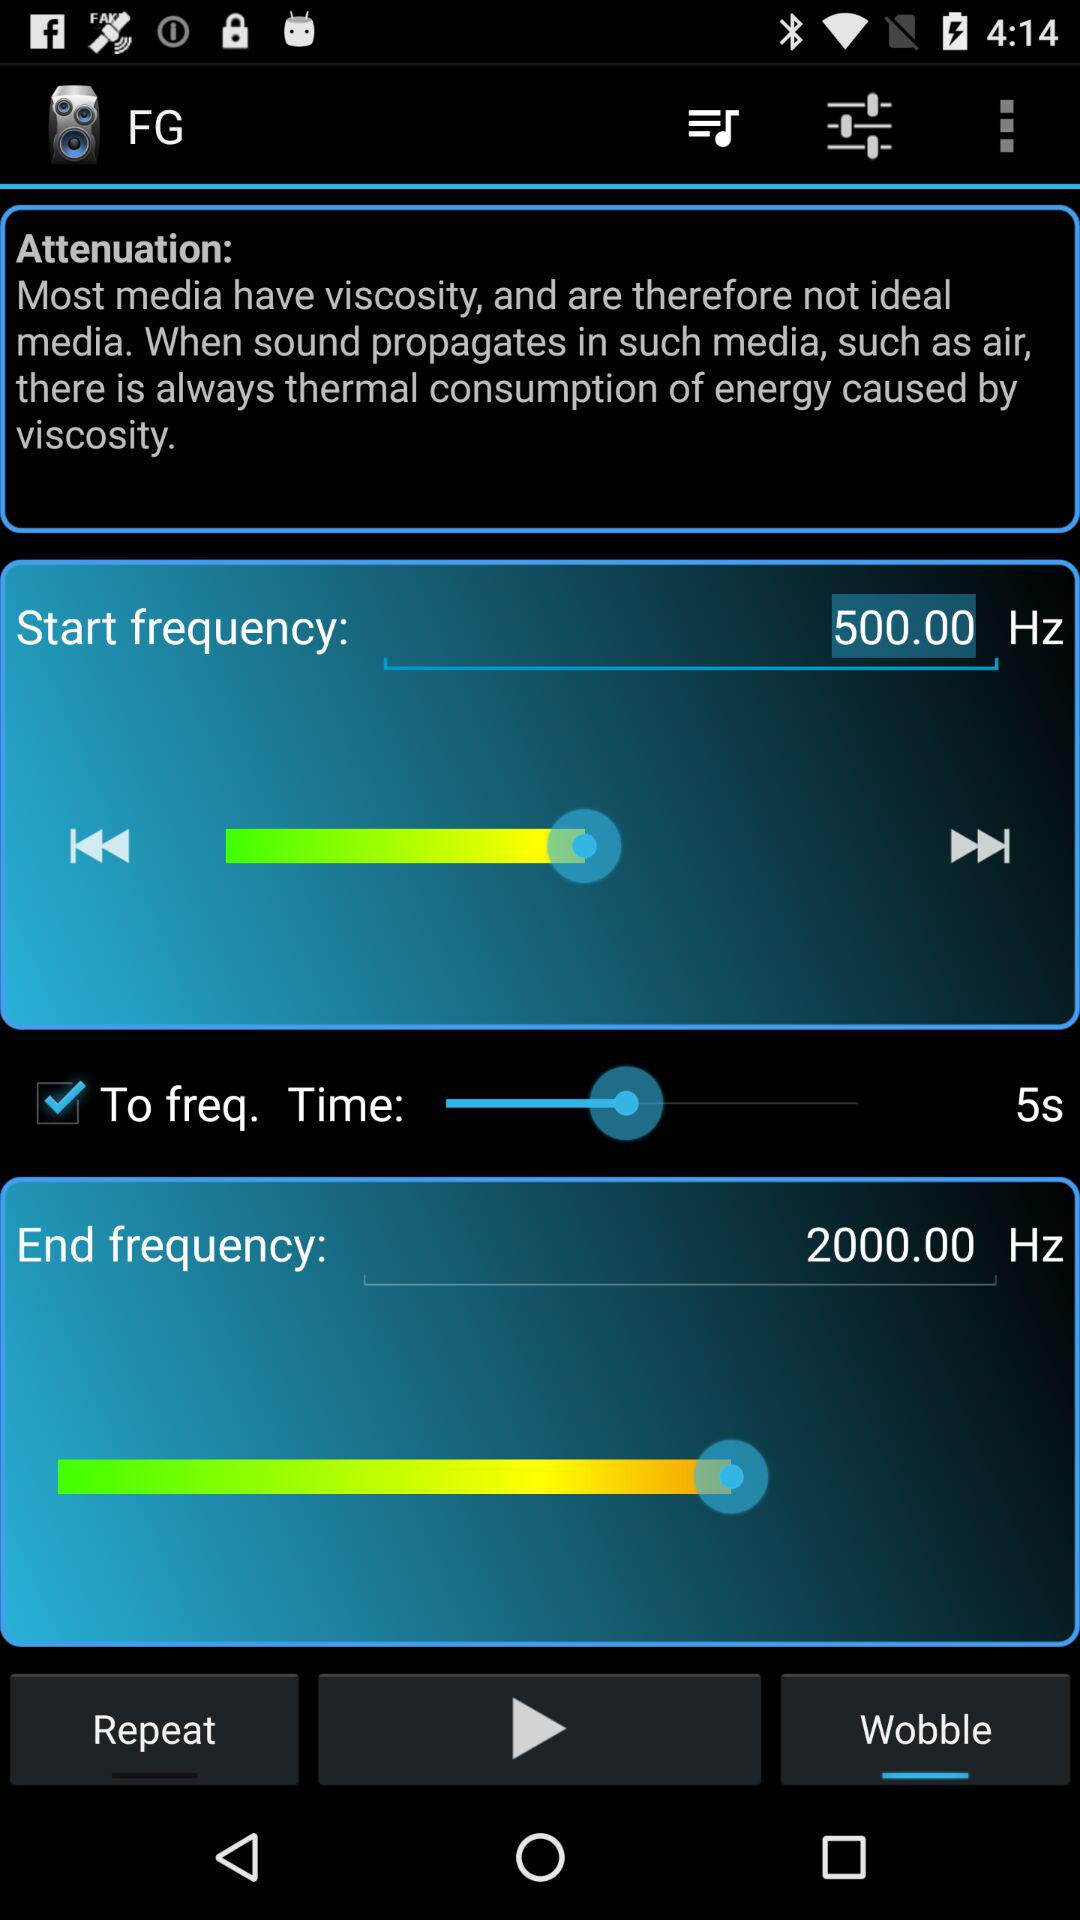What is the end frequency? The end frequency is 2000 Hz. 